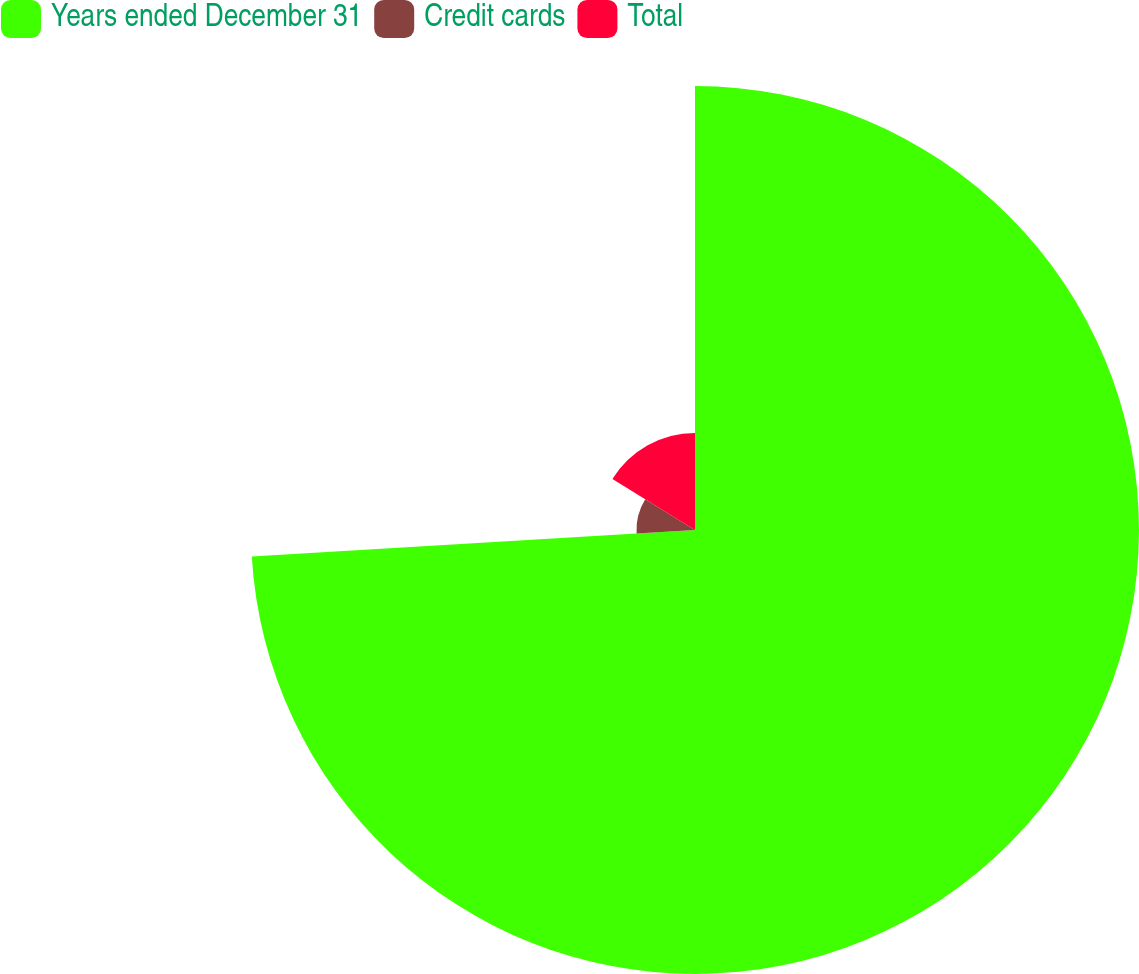Convert chart to OTSL. <chart><loc_0><loc_0><loc_500><loc_500><pie_chart><fcel>Years ended December 31<fcel>Credit cards<fcel>Total<nl><fcel>74.05%<fcel>9.76%<fcel>16.19%<nl></chart> 